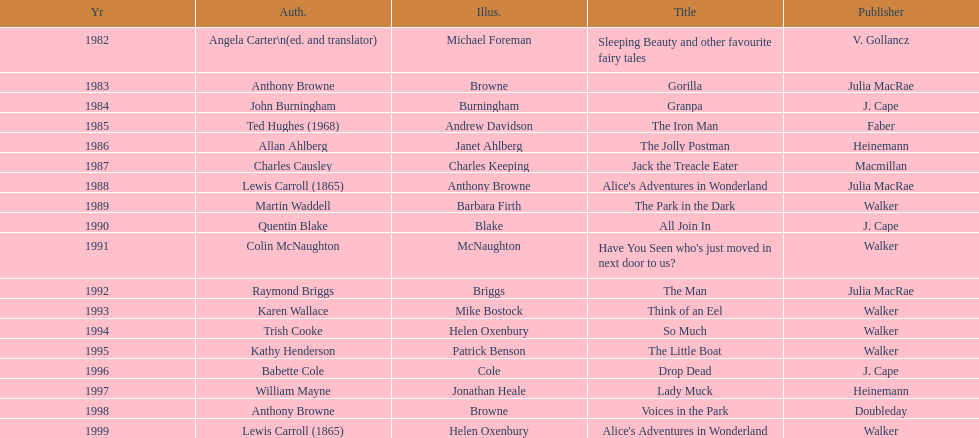Parse the table in full. {'header': ['Yr', 'Auth.', 'Illus.', 'Title', 'Publisher'], 'rows': [['1982', 'Angela Carter\\n(ed. and translator)', 'Michael Foreman', 'Sleeping Beauty and other favourite fairy tales', 'V. Gollancz'], ['1983', 'Anthony Browne', 'Browne', 'Gorilla', 'Julia MacRae'], ['1984', 'John Burningham', 'Burningham', 'Granpa', 'J. Cape'], ['1985', 'Ted Hughes (1968)', 'Andrew Davidson', 'The Iron Man', 'Faber'], ['1986', 'Allan Ahlberg', 'Janet Ahlberg', 'The Jolly Postman', 'Heinemann'], ['1987', 'Charles Causley', 'Charles Keeping', 'Jack the Treacle Eater', 'Macmillan'], ['1988', 'Lewis Carroll (1865)', 'Anthony Browne', "Alice's Adventures in Wonderland", 'Julia MacRae'], ['1989', 'Martin Waddell', 'Barbara Firth', 'The Park in the Dark', 'Walker'], ['1990', 'Quentin Blake', 'Blake', 'All Join In', 'J. Cape'], ['1991', 'Colin McNaughton', 'McNaughton', "Have You Seen who's just moved in next door to us?", 'Walker'], ['1992', 'Raymond Briggs', 'Briggs', 'The Man', 'Julia MacRae'], ['1993', 'Karen Wallace', 'Mike Bostock', 'Think of an Eel', 'Walker'], ['1994', 'Trish Cooke', 'Helen Oxenbury', 'So Much', 'Walker'], ['1995', 'Kathy Henderson', 'Patrick Benson', 'The Little Boat', 'Walker'], ['1996', 'Babette Cole', 'Cole', 'Drop Dead', 'J. Cape'], ['1997', 'William Mayne', 'Jonathan Heale', 'Lady Muck', 'Heinemann'], ['1998', 'Anthony Browne', 'Browne', 'Voices in the Park', 'Doubleday'], ['1999', 'Lewis Carroll (1865)', 'Helen Oxenbury', "Alice's Adventures in Wonderland", 'Walker']]} What's the difference in years between angela carter's title and anthony browne's? 1. 